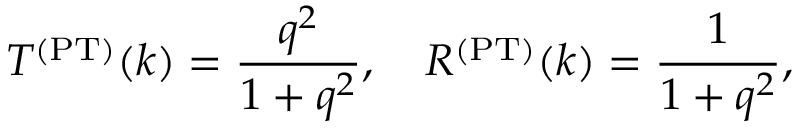Convert formula to latex. <formula><loc_0><loc_0><loc_500><loc_500>T ^ { ( P T ) } ( k ) = \frac { q ^ { 2 } } { 1 + q ^ { 2 } } , \quad R ^ { ( P T ) } ( k ) = \frac { 1 } { 1 + q ^ { 2 } } ,</formula> 